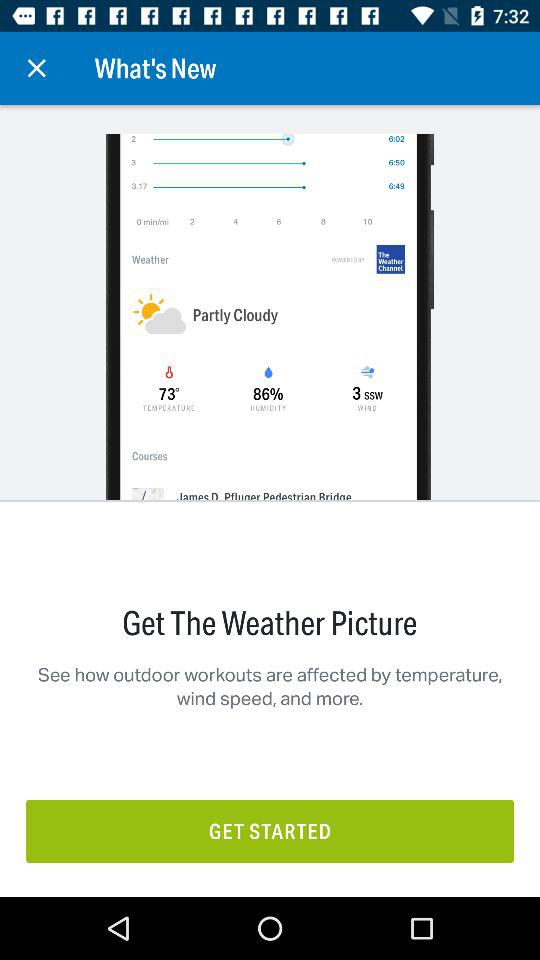What is the given humidity? The humidity is 86%. 